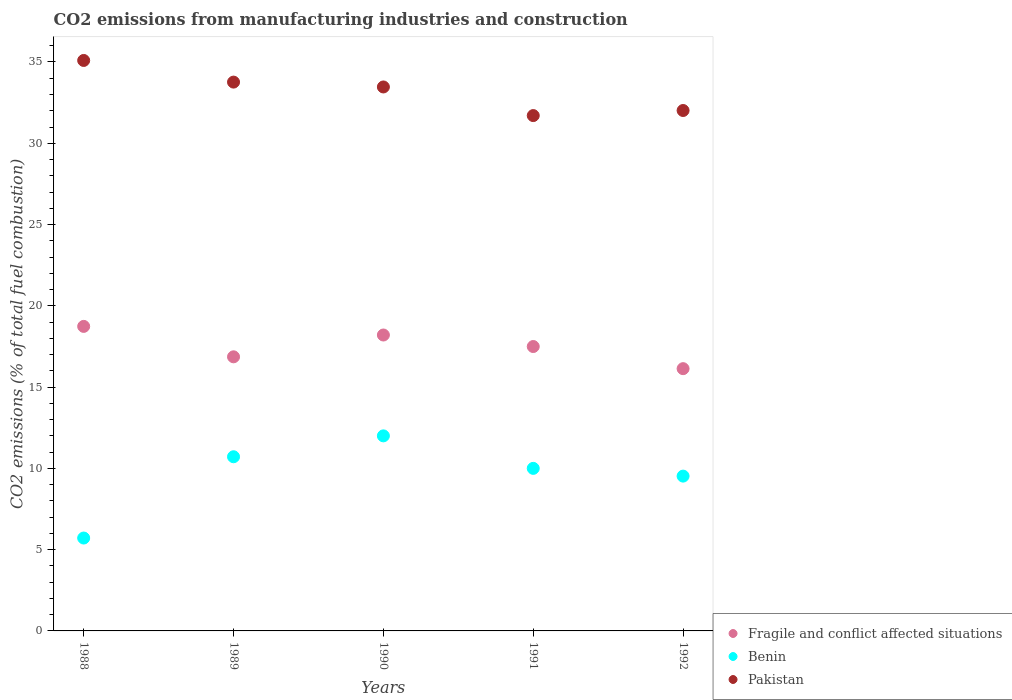Is the number of dotlines equal to the number of legend labels?
Make the answer very short. Yes. What is the amount of CO2 emitted in Fragile and conflict affected situations in 1990?
Keep it short and to the point. 18.2. Across all years, what is the maximum amount of CO2 emitted in Pakistan?
Provide a short and direct response. 35.09. Across all years, what is the minimum amount of CO2 emitted in Pakistan?
Provide a short and direct response. 31.7. In which year was the amount of CO2 emitted in Benin maximum?
Ensure brevity in your answer.  1990. What is the total amount of CO2 emitted in Benin in the graph?
Your answer should be very brief. 47.95. What is the difference between the amount of CO2 emitted in Pakistan in 1989 and that in 1991?
Offer a very short reply. 2.06. What is the difference between the amount of CO2 emitted in Pakistan in 1989 and the amount of CO2 emitted in Fragile and conflict affected situations in 1990?
Your answer should be very brief. 15.56. What is the average amount of CO2 emitted in Fragile and conflict affected situations per year?
Your response must be concise. 17.49. In the year 1991, what is the difference between the amount of CO2 emitted in Benin and amount of CO2 emitted in Fragile and conflict affected situations?
Your answer should be compact. -7.5. What is the ratio of the amount of CO2 emitted in Fragile and conflict affected situations in 1988 to that in 1991?
Give a very brief answer. 1.07. Is the amount of CO2 emitted in Benin in 1990 less than that in 1992?
Offer a very short reply. No. Is the difference between the amount of CO2 emitted in Benin in 1989 and 1992 greater than the difference between the amount of CO2 emitted in Fragile and conflict affected situations in 1989 and 1992?
Give a very brief answer. Yes. What is the difference between the highest and the second highest amount of CO2 emitted in Pakistan?
Your response must be concise. 1.33. What is the difference between the highest and the lowest amount of CO2 emitted in Pakistan?
Your response must be concise. 3.39. In how many years, is the amount of CO2 emitted in Fragile and conflict affected situations greater than the average amount of CO2 emitted in Fragile and conflict affected situations taken over all years?
Make the answer very short. 3. Is the sum of the amount of CO2 emitted in Fragile and conflict affected situations in 1988 and 1991 greater than the maximum amount of CO2 emitted in Benin across all years?
Give a very brief answer. Yes. Is it the case that in every year, the sum of the amount of CO2 emitted in Pakistan and amount of CO2 emitted in Benin  is greater than the amount of CO2 emitted in Fragile and conflict affected situations?
Your answer should be compact. Yes. Is the amount of CO2 emitted in Benin strictly greater than the amount of CO2 emitted in Pakistan over the years?
Offer a terse response. No. How many years are there in the graph?
Provide a succinct answer. 5. What is the difference between two consecutive major ticks on the Y-axis?
Keep it short and to the point. 5. Does the graph contain any zero values?
Make the answer very short. No. How are the legend labels stacked?
Offer a terse response. Vertical. What is the title of the graph?
Keep it short and to the point. CO2 emissions from manufacturing industries and construction. What is the label or title of the X-axis?
Offer a very short reply. Years. What is the label or title of the Y-axis?
Your answer should be compact. CO2 emissions (% of total fuel combustion). What is the CO2 emissions (% of total fuel combustion) in Fragile and conflict affected situations in 1988?
Keep it short and to the point. 18.73. What is the CO2 emissions (% of total fuel combustion) in Benin in 1988?
Your answer should be compact. 5.71. What is the CO2 emissions (% of total fuel combustion) in Pakistan in 1988?
Keep it short and to the point. 35.09. What is the CO2 emissions (% of total fuel combustion) of Fragile and conflict affected situations in 1989?
Your answer should be very brief. 16.86. What is the CO2 emissions (% of total fuel combustion) in Benin in 1989?
Make the answer very short. 10.71. What is the CO2 emissions (% of total fuel combustion) of Pakistan in 1989?
Provide a succinct answer. 33.76. What is the CO2 emissions (% of total fuel combustion) in Fragile and conflict affected situations in 1990?
Give a very brief answer. 18.2. What is the CO2 emissions (% of total fuel combustion) of Benin in 1990?
Offer a very short reply. 12. What is the CO2 emissions (% of total fuel combustion) in Pakistan in 1990?
Your response must be concise. 33.46. What is the CO2 emissions (% of total fuel combustion) in Fragile and conflict affected situations in 1991?
Your response must be concise. 17.5. What is the CO2 emissions (% of total fuel combustion) of Benin in 1991?
Your answer should be compact. 10. What is the CO2 emissions (% of total fuel combustion) in Pakistan in 1991?
Your answer should be very brief. 31.7. What is the CO2 emissions (% of total fuel combustion) in Fragile and conflict affected situations in 1992?
Make the answer very short. 16.13. What is the CO2 emissions (% of total fuel combustion) of Benin in 1992?
Give a very brief answer. 9.52. What is the CO2 emissions (% of total fuel combustion) in Pakistan in 1992?
Ensure brevity in your answer.  32.02. Across all years, what is the maximum CO2 emissions (% of total fuel combustion) in Fragile and conflict affected situations?
Offer a terse response. 18.73. Across all years, what is the maximum CO2 emissions (% of total fuel combustion) of Benin?
Your answer should be compact. 12. Across all years, what is the maximum CO2 emissions (% of total fuel combustion) in Pakistan?
Your response must be concise. 35.09. Across all years, what is the minimum CO2 emissions (% of total fuel combustion) in Fragile and conflict affected situations?
Ensure brevity in your answer.  16.13. Across all years, what is the minimum CO2 emissions (% of total fuel combustion) in Benin?
Offer a very short reply. 5.71. Across all years, what is the minimum CO2 emissions (% of total fuel combustion) of Pakistan?
Provide a succinct answer. 31.7. What is the total CO2 emissions (% of total fuel combustion) in Fragile and conflict affected situations in the graph?
Keep it short and to the point. 87.43. What is the total CO2 emissions (% of total fuel combustion) in Benin in the graph?
Offer a terse response. 47.95. What is the total CO2 emissions (% of total fuel combustion) of Pakistan in the graph?
Keep it short and to the point. 166.04. What is the difference between the CO2 emissions (% of total fuel combustion) in Fragile and conflict affected situations in 1988 and that in 1989?
Your response must be concise. 1.87. What is the difference between the CO2 emissions (% of total fuel combustion) in Pakistan in 1988 and that in 1989?
Offer a very short reply. 1.33. What is the difference between the CO2 emissions (% of total fuel combustion) in Fragile and conflict affected situations in 1988 and that in 1990?
Ensure brevity in your answer.  0.53. What is the difference between the CO2 emissions (% of total fuel combustion) in Benin in 1988 and that in 1990?
Your answer should be very brief. -6.29. What is the difference between the CO2 emissions (% of total fuel combustion) of Pakistan in 1988 and that in 1990?
Ensure brevity in your answer.  1.63. What is the difference between the CO2 emissions (% of total fuel combustion) in Fragile and conflict affected situations in 1988 and that in 1991?
Provide a succinct answer. 1.24. What is the difference between the CO2 emissions (% of total fuel combustion) of Benin in 1988 and that in 1991?
Keep it short and to the point. -4.29. What is the difference between the CO2 emissions (% of total fuel combustion) of Pakistan in 1988 and that in 1991?
Offer a very short reply. 3.39. What is the difference between the CO2 emissions (% of total fuel combustion) in Fragile and conflict affected situations in 1988 and that in 1992?
Your answer should be compact. 2.6. What is the difference between the CO2 emissions (% of total fuel combustion) in Benin in 1988 and that in 1992?
Offer a terse response. -3.81. What is the difference between the CO2 emissions (% of total fuel combustion) in Pakistan in 1988 and that in 1992?
Provide a short and direct response. 3.08. What is the difference between the CO2 emissions (% of total fuel combustion) in Fragile and conflict affected situations in 1989 and that in 1990?
Your answer should be very brief. -1.34. What is the difference between the CO2 emissions (% of total fuel combustion) of Benin in 1989 and that in 1990?
Provide a short and direct response. -1.29. What is the difference between the CO2 emissions (% of total fuel combustion) of Pakistan in 1989 and that in 1990?
Provide a short and direct response. 0.3. What is the difference between the CO2 emissions (% of total fuel combustion) in Fragile and conflict affected situations in 1989 and that in 1991?
Your answer should be compact. -0.63. What is the difference between the CO2 emissions (% of total fuel combustion) of Pakistan in 1989 and that in 1991?
Give a very brief answer. 2.06. What is the difference between the CO2 emissions (% of total fuel combustion) of Fragile and conflict affected situations in 1989 and that in 1992?
Your answer should be very brief. 0.73. What is the difference between the CO2 emissions (% of total fuel combustion) in Benin in 1989 and that in 1992?
Give a very brief answer. 1.19. What is the difference between the CO2 emissions (% of total fuel combustion) of Pakistan in 1989 and that in 1992?
Ensure brevity in your answer.  1.75. What is the difference between the CO2 emissions (% of total fuel combustion) in Fragile and conflict affected situations in 1990 and that in 1991?
Provide a short and direct response. 0.71. What is the difference between the CO2 emissions (% of total fuel combustion) of Pakistan in 1990 and that in 1991?
Your response must be concise. 1.76. What is the difference between the CO2 emissions (% of total fuel combustion) in Fragile and conflict affected situations in 1990 and that in 1992?
Provide a short and direct response. 2.07. What is the difference between the CO2 emissions (% of total fuel combustion) in Benin in 1990 and that in 1992?
Offer a terse response. 2.48. What is the difference between the CO2 emissions (% of total fuel combustion) in Pakistan in 1990 and that in 1992?
Provide a short and direct response. 1.45. What is the difference between the CO2 emissions (% of total fuel combustion) in Fragile and conflict affected situations in 1991 and that in 1992?
Offer a terse response. 1.36. What is the difference between the CO2 emissions (% of total fuel combustion) of Benin in 1991 and that in 1992?
Ensure brevity in your answer.  0.48. What is the difference between the CO2 emissions (% of total fuel combustion) in Pakistan in 1991 and that in 1992?
Keep it short and to the point. -0.31. What is the difference between the CO2 emissions (% of total fuel combustion) of Fragile and conflict affected situations in 1988 and the CO2 emissions (% of total fuel combustion) of Benin in 1989?
Keep it short and to the point. 8.02. What is the difference between the CO2 emissions (% of total fuel combustion) in Fragile and conflict affected situations in 1988 and the CO2 emissions (% of total fuel combustion) in Pakistan in 1989?
Provide a succinct answer. -15.03. What is the difference between the CO2 emissions (% of total fuel combustion) of Benin in 1988 and the CO2 emissions (% of total fuel combustion) of Pakistan in 1989?
Your answer should be very brief. -28.05. What is the difference between the CO2 emissions (% of total fuel combustion) in Fragile and conflict affected situations in 1988 and the CO2 emissions (% of total fuel combustion) in Benin in 1990?
Your answer should be very brief. 6.73. What is the difference between the CO2 emissions (% of total fuel combustion) in Fragile and conflict affected situations in 1988 and the CO2 emissions (% of total fuel combustion) in Pakistan in 1990?
Keep it short and to the point. -14.73. What is the difference between the CO2 emissions (% of total fuel combustion) of Benin in 1988 and the CO2 emissions (% of total fuel combustion) of Pakistan in 1990?
Offer a terse response. -27.75. What is the difference between the CO2 emissions (% of total fuel combustion) of Fragile and conflict affected situations in 1988 and the CO2 emissions (% of total fuel combustion) of Benin in 1991?
Provide a succinct answer. 8.73. What is the difference between the CO2 emissions (% of total fuel combustion) in Fragile and conflict affected situations in 1988 and the CO2 emissions (% of total fuel combustion) in Pakistan in 1991?
Your answer should be compact. -12.97. What is the difference between the CO2 emissions (% of total fuel combustion) of Benin in 1988 and the CO2 emissions (% of total fuel combustion) of Pakistan in 1991?
Make the answer very short. -25.99. What is the difference between the CO2 emissions (% of total fuel combustion) in Fragile and conflict affected situations in 1988 and the CO2 emissions (% of total fuel combustion) in Benin in 1992?
Ensure brevity in your answer.  9.21. What is the difference between the CO2 emissions (% of total fuel combustion) in Fragile and conflict affected situations in 1988 and the CO2 emissions (% of total fuel combustion) in Pakistan in 1992?
Offer a very short reply. -13.28. What is the difference between the CO2 emissions (% of total fuel combustion) of Benin in 1988 and the CO2 emissions (% of total fuel combustion) of Pakistan in 1992?
Your response must be concise. -26.3. What is the difference between the CO2 emissions (% of total fuel combustion) in Fragile and conflict affected situations in 1989 and the CO2 emissions (% of total fuel combustion) in Benin in 1990?
Your response must be concise. 4.86. What is the difference between the CO2 emissions (% of total fuel combustion) of Fragile and conflict affected situations in 1989 and the CO2 emissions (% of total fuel combustion) of Pakistan in 1990?
Make the answer very short. -16.6. What is the difference between the CO2 emissions (% of total fuel combustion) of Benin in 1989 and the CO2 emissions (% of total fuel combustion) of Pakistan in 1990?
Your answer should be very brief. -22.75. What is the difference between the CO2 emissions (% of total fuel combustion) of Fragile and conflict affected situations in 1989 and the CO2 emissions (% of total fuel combustion) of Benin in 1991?
Give a very brief answer. 6.86. What is the difference between the CO2 emissions (% of total fuel combustion) in Fragile and conflict affected situations in 1989 and the CO2 emissions (% of total fuel combustion) in Pakistan in 1991?
Offer a terse response. -14.84. What is the difference between the CO2 emissions (% of total fuel combustion) in Benin in 1989 and the CO2 emissions (% of total fuel combustion) in Pakistan in 1991?
Provide a succinct answer. -20.99. What is the difference between the CO2 emissions (% of total fuel combustion) of Fragile and conflict affected situations in 1989 and the CO2 emissions (% of total fuel combustion) of Benin in 1992?
Your answer should be compact. 7.34. What is the difference between the CO2 emissions (% of total fuel combustion) of Fragile and conflict affected situations in 1989 and the CO2 emissions (% of total fuel combustion) of Pakistan in 1992?
Give a very brief answer. -15.15. What is the difference between the CO2 emissions (% of total fuel combustion) of Benin in 1989 and the CO2 emissions (% of total fuel combustion) of Pakistan in 1992?
Offer a very short reply. -21.3. What is the difference between the CO2 emissions (% of total fuel combustion) in Fragile and conflict affected situations in 1990 and the CO2 emissions (% of total fuel combustion) in Benin in 1991?
Provide a succinct answer. 8.2. What is the difference between the CO2 emissions (% of total fuel combustion) of Fragile and conflict affected situations in 1990 and the CO2 emissions (% of total fuel combustion) of Pakistan in 1991?
Give a very brief answer. -13.5. What is the difference between the CO2 emissions (% of total fuel combustion) in Benin in 1990 and the CO2 emissions (% of total fuel combustion) in Pakistan in 1991?
Give a very brief answer. -19.7. What is the difference between the CO2 emissions (% of total fuel combustion) in Fragile and conflict affected situations in 1990 and the CO2 emissions (% of total fuel combustion) in Benin in 1992?
Provide a short and direct response. 8.68. What is the difference between the CO2 emissions (% of total fuel combustion) of Fragile and conflict affected situations in 1990 and the CO2 emissions (% of total fuel combustion) of Pakistan in 1992?
Provide a short and direct response. -13.81. What is the difference between the CO2 emissions (% of total fuel combustion) of Benin in 1990 and the CO2 emissions (% of total fuel combustion) of Pakistan in 1992?
Offer a very short reply. -20.02. What is the difference between the CO2 emissions (% of total fuel combustion) of Fragile and conflict affected situations in 1991 and the CO2 emissions (% of total fuel combustion) of Benin in 1992?
Offer a terse response. 7.97. What is the difference between the CO2 emissions (% of total fuel combustion) of Fragile and conflict affected situations in 1991 and the CO2 emissions (% of total fuel combustion) of Pakistan in 1992?
Your answer should be very brief. -14.52. What is the difference between the CO2 emissions (% of total fuel combustion) in Benin in 1991 and the CO2 emissions (% of total fuel combustion) in Pakistan in 1992?
Your response must be concise. -22.02. What is the average CO2 emissions (% of total fuel combustion) of Fragile and conflict affected situations per year?
Ensure brevity in your answer.  17.49. What is the average CO2 emissions (% of total fuel combustion) of Benin per year?
Your answer should be very brief. 9.59. What is the average CO2 emissions (% of total fuel combustion) of Pakistan per year?
Offer a very short reply. 33.21. In the year 1988, what is the difference between the CO2 emissions (% of total fuel combustion) in Fragile and conflict affected situations and CO2 emissions (% of total fuel combustion) in Benin?
Keep it short and to the point. 13.02. In the year 1988, what is the difference between the CO2 emissions (% of total fuel combustion) of Fragile and conflict affected situations and CO2 emissions (% of total fuel combustion) of Pakistan?
Your answer should be compact. -16.36. In the year 1988, what is the difference between the CO2 emissions (% of total fuel combustion) in Benin and CO2 emissions (% of total fuel combustion) in Pakistan?
Keep it short and to the point. -29.38. In the year 1989, what is the difference between the CO2 emissions (% of total fuel combustion) of Fragile and conflict affected situations and CO2 emissions (% of total fuel combustion) of Benin?
Offer a terse response. 6.15. In the year 1989, what is the difference between the CO2 emissions (% of total fuel combustion) in Fragile and conflict affected situations and CO2 emissions (% of total fuel combustion) in Pakistan?
Provide a succinct answer. -16.9. In the year 1989, what is the difference between the CO2 emissions (% of total fuel combustion) in Benin and CO2 emissions (% of total fuel combustion) in Pakistan?
Your answer should be very brief. -23.05. In the year 1990, what is the difference between the CO2 emissions (% of total fuel combustion) of Fragile and conflict affected situations and CO2 emissions (% of total fuel combustion) of Benin?
Offer a very short reply. 6.2. In the year 1990, what is the difference between the CO2 emissions (% of total fuel combustion) in Fragile and conflict affected situations and CO2 emissions (% of total fuel combustion) in Pakistan?
Provide a short and direct response. -15.26. In the year 1990, what is the difference between the CO2 emissions (% of total fuel combustion) in Benin and CO2 emissions (% of total fuel combustion) in Pakistan?
Your answer should be very brief. -21.46. In the year 1991, what is the difference between the CO2 emissions (% of total fuel combustion) of Fragile and conflict affected situations and CO2 emissions (% of total fuel combustion) of Benin?
Your answer should be compact. 7.5. In the year 1991, what is the difference between the CO2 emissions (% of total fuel combustion) of Fragile and conflict affected situations and CO2 emissions (% of total fuel combustion) of Pakistan?
Your answer should be very brief. -14.21. In the year 1991, what is the difference between the CO2 emissions (% of total fuel combustion) of Benin and CO2 emissions (% of total fuel combustion) of Pakistan?
Offer a very short reply. -21.7. In the year 1992, what is the difference between the CO2 emissions (% of total fuel combustion) in Fragile and conflict affected situations and CO2 emissions (% of total fuel combustion) in Benin?
Your answer should be compact. 6.61. In the year 1992, what is the difference between the CO2 emissions (% of total fuel combustion) of Fragile and conflict affected situations and CO2 emissions (% of total fuel combustion) of Pakistan?
Your answer should be compact. -15.88. In the year 1992, what is the difference between the CO2 emissions (% of total fuel combustion) of Benin and CO2 emissions (% of total fuel combustion) of Pakistan?
Make the answer very short. -22.49. What is the ratio of the CO2 emissions (% of total fuel combustion) in Fragile and conflict affected situations in 1988 to that in 1989?
Give a very brief answer. 1.11. What is the ratio of the CO2 emissions (% of total fuel combustion) of Benin in 1988 to that in 1989?
Keep it short and to the point. 0.53. What is the ratio of the CO2 emissions (% of total fuel combustion) of Pakistan in 1988 to that in 1989?
Your answer should be compact. 1.04. What is the ratio of the CO2 emissions (% of total fuel combustion) of Fragile and conflict affected situations in 1988 to that in 1990?
Keep it short and to the point. 1.03. What is the ratio of the CO2 emissions (% of total fuel combustion) in Benin in 1988 to that in 1990?
Offer a terse response. 0.48. What is the ratio of the CO2 emissions (% of total fuel combustion) in Pakistan in 1988 to that in 1990?
Provide a short and direct response. 1.05. What is the ratio of the CO2 emissions (% of total fuel combustion) in Fragile and conflict affected situations in 1988 to that in 1991?
Give a very brief answer. 1.07. What is the ratio of the CO2 emissions (% of total fuel combustion) of Benin in 1988 to that in 1991?
Your answer should be very brief. 0.57. What is the ratio of the CO2 emissions (% of total fuel combustion) of Pakistan in 1988 to that in 1991?
Offer a terse response. 1.11. What is the ratio of the CO2 emissions (% of total fuel combustion) in Fragile and conflict affected situations in 1988 to that in 1992?
Give a very brief answer. 1.16. What is the ratio of the CO2 emissions (% of total fuel combustion) in Pakistan in 1988 to that in 1992?
Offer a very short reply. 1.1. What is the ratio of the CO2 emissions (% of total fuel combustion) of Fragile and conflict affected situations in 1989 to that in 1990?
Keep it short and to the point. 0.93. What is the ratio of the CO2 emissions (% of total fuel combustion) of Benin in 1989 to that in 1990?
Your response must be concise. 0.89. What is the ratio of the CO2 emissions (% of total fuel combustion) in Pakistan in 1989 to that in 1990?
Your answer should be compact. 1.01. What is the ratio of the CO2 emissions (% of total fuel combustion) in Fragile and conflict affected situations in 1989 to that in 1991?
Your answer should be compact. 0.96. What is the ratio of the CO2 emissions (% of total fuel combustion) in Benin in 1989 to that in 1991?
Offer a very short reply. 1.07. What is the ratio of the CO2 emissions (% of total fuel combustion) in Pakistan in 1989 to that in 1991?
Your answer should be compact. 1.06. What is the ratio of the CO2 emissions (% of total fuel combustion) in Fragile and conflict affected situations in 1989 to that in 1992?
Offer a terse response. 1.05. What is the ratio of the CO2 emissions (% of total fuel combustion) of Pakistan in 1989 to that in 1992?
Provide a succinct answer. 1.05. What is the ratio of the CO2 emissions (% of total fuel combustion) in Fragile and conflict affected situations in 1990 to that in 1991?
Make the answer very short. 1.04. What is the ratio of the CO2 emissions (% of total fuel combustion) in Benin in 1990 to that in 1991?
Provide a short and direct response. 1.2. What is the ratio of the CO2 emissions (% of total fuel combustion) in Pakistan in 1990 to that in 1991?
Offer a very short reply. 1.06. What is the ratio of the CO2 emissions (% of total fuel combustion) of Fragile and conflict affected situations in 1990 to that in 1992?
Offer a terse response. 1.13. What is the ratio of the CO2 emissions (% of total fuel combustion) in Benin in 1990 to that in 1992?
Your answer should be compact. 1.26. What is the ratio of the CO2 emissions (% of total fuel combustion) of Pakistan in 1990 to that in 1992?
Ensure brevity in your answer.  1.05. What is the ratio of the CO2 emissions (% of total fuel combustion) of Fragile and conflict affected situations in 1991 to that in 1992?
Provide a succinct answer. 1.08. What is the ratio of the CO2 emissions (% of total fuel combustion) of Benin in 1991 to that in 1992?
Offer a terse response. 1.05. What is the ratio of the CO2 emissions (% of total fuel combustion) in Pakistan in 1991 to that in 1992?
Provide a succinct answer. 0.99. What is the difference between the highest and the second highest CO2 emissions (% of total fuel combustion) of Fragile and conflict affected situations?
Provide a succinct answer. 0.53. What is the difference between the highest and the second highest CO2 emissions (% of total fuel combustion) of Benin?
Ensure brevity in your answer.  1.29. What is the difference between the highest and the second highest CO2 emissions (% of total fuel combustion) of Pakistan?
Ensure brevity in your answer.  1.33. What is the difference between the highest and the lowest CO2 emissions (% of total fuel combustion) of Fragile and conflict affected situations?
Your answer should be compact. 2.6. What is the difference between the highest and the lowest CO2 emissions (% of total fuel combustion) of Benin?
Make the answer very short. 6.29. What is the difference between the highest and the lowest CO2 emissions (% of total fuel combustion) in Pakistan?
Your response must be concise. 3.39. 